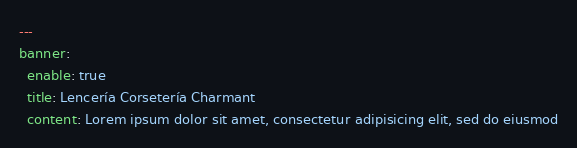<code> <loc_0><loc_0><loc_500><loc_500><_YAML_>---
banner:
  enable: true
  title: Lencería Corsetería Charmant
  content: Lorem ipsum dolor sit amet, consectetur adipisicing elit, sed do eiusmod</code> 